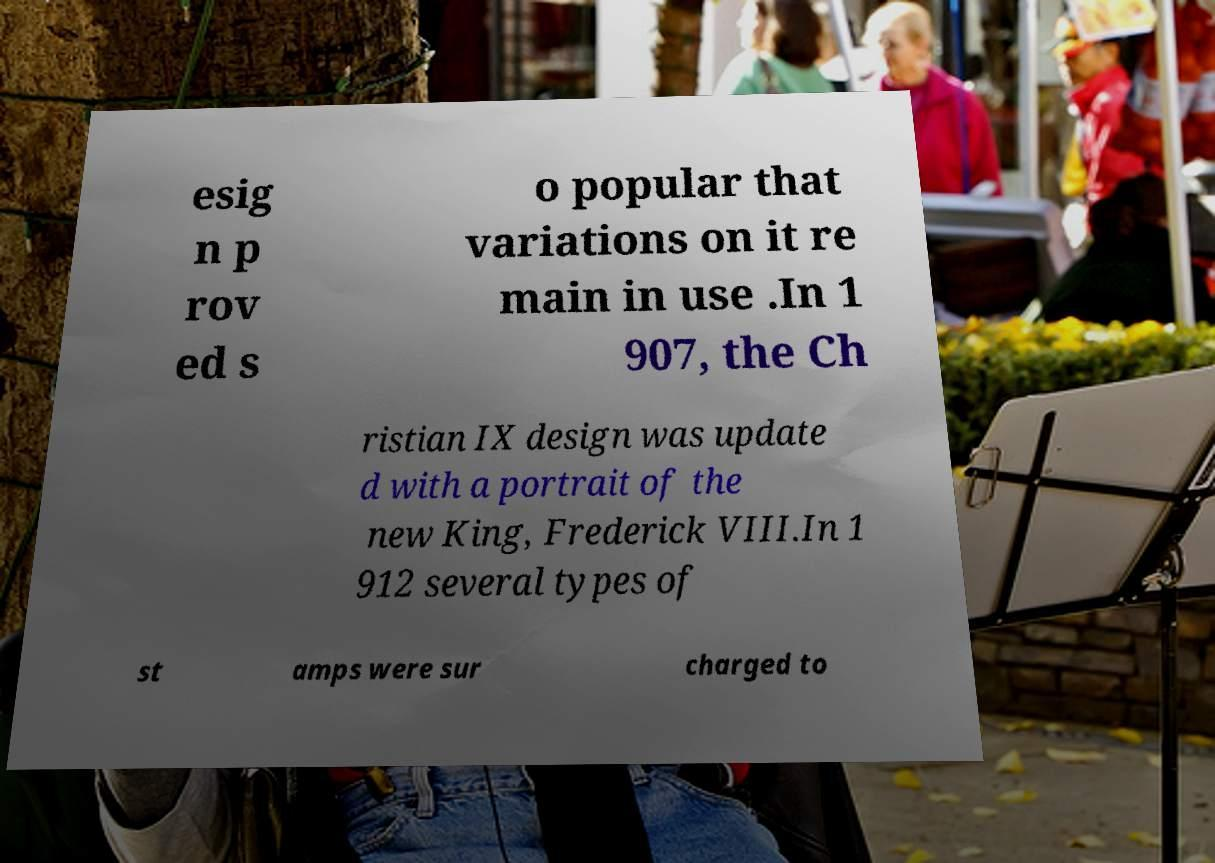Could you assist in decoding the text presented in this image and type it out clearly? esig n p rov ed s o popular that variations on it re main in use .In 1 907, the Ch ristian IX design was update d with a portrait of the new King, Frederick VIII.In 1 912 several types of st amps were sur charged to 